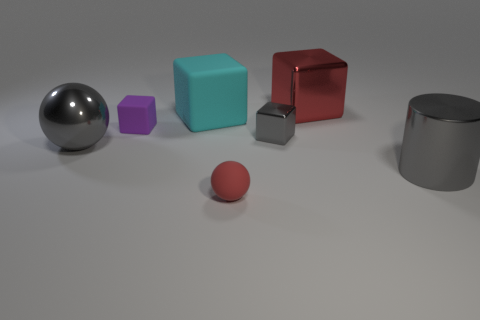Add 2 tiny red rubber things. How many objects exist? 9 Subtract all balls. How many objects are left? 5 Add 7 gray things. How many gray things exist? 10 Subtract 0 green cylinders. How many objects are left? 7 Subtract all large gray blocks. Subtract all small purple cubes. How many objects are left? 6 Add 7 tiny purple matte blocks. How many tiny purple matte blocks are left? 8 